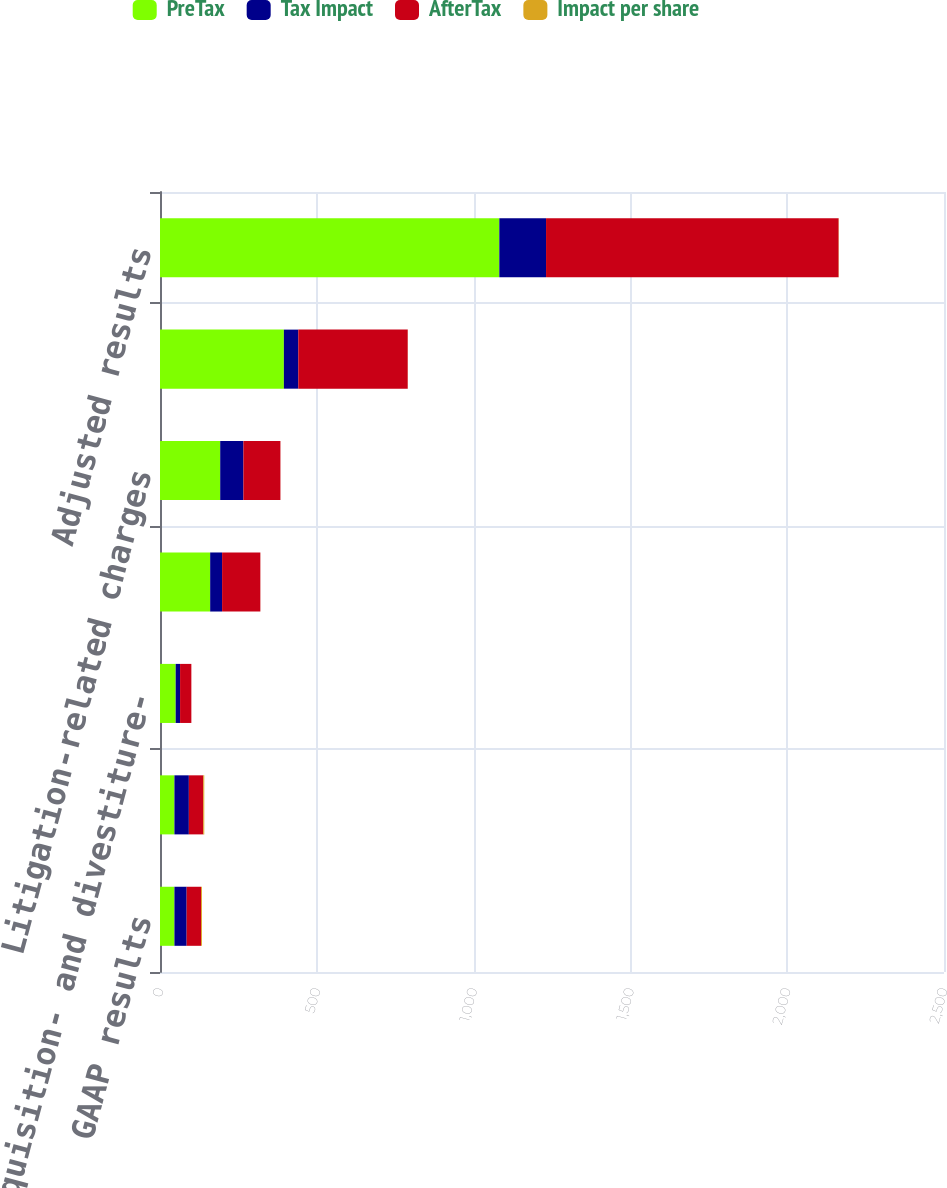Convert chart to OTSL. <chart><loc_0><loc_0><loc_500><loc_500><stacked_bar_chart><ecel><fcel>GAAP results<fcel>Goodwill and other intangible<fcel>Acquisition- and divestiture-<fcel>Restructuring-related charges<fcel>Litigation-related charges<fcel>Amortization expense<fcel>Adjusted results<nl><fcel>PreTax<fcel>46<fcel>46<fcel>50<fcel>160<fcel>192<fcel>395<fcel>1082<nl><fcel>Tax Impact<fcel>39<fcel>46<fcel>14<fcel>38<fcel>74<fcel>46<fcel>149<nl><fcel>AfterTax<fcel>46<fcel>46<fcel>36<fcel>122<fcel>118<fcel>349<fcel>933<nl><fcel>Impact per share<fcel>2.89<fcel>3.15<fcel>0.02<fcel>0.09<fcel>0.08<fcel>0.25<fcel>0.66<nl></chart> 